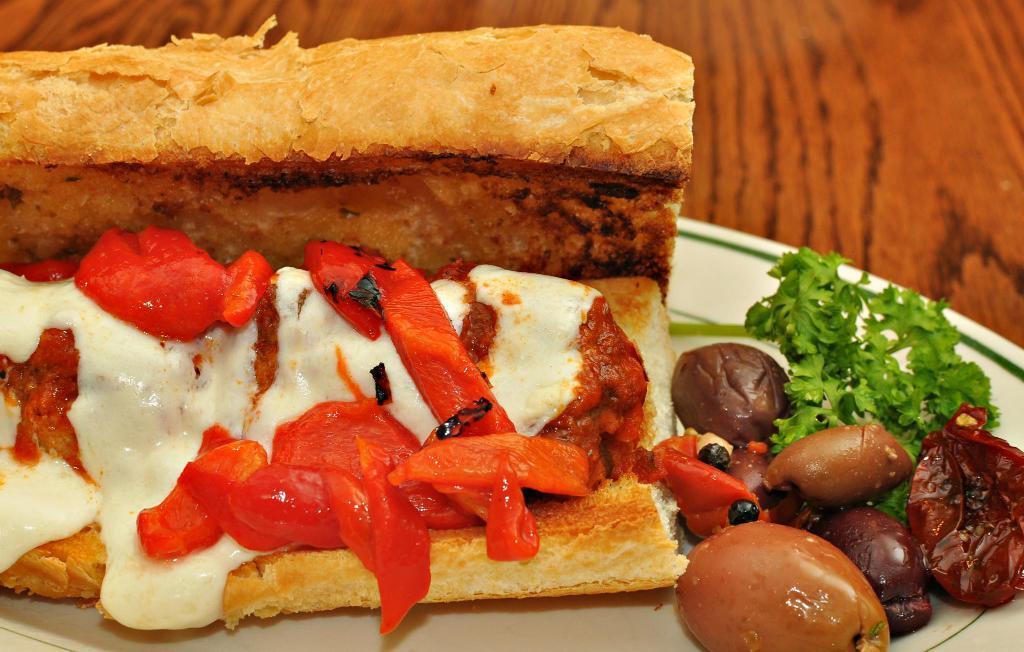How would you summarize this image in a sentence or two? In this picture we can see food items and leaves on a plate and this plate is placed on a wooden platform. 